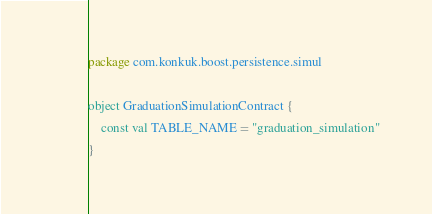<code> <loc_0><loc_0><loc_500><loc_500><_Kotlin_>package com.konkuk.boost.persistence.simul

object GraduationSimulationContract {
    const val TABLE_NAME = "graduation_simulation"
}</code> 